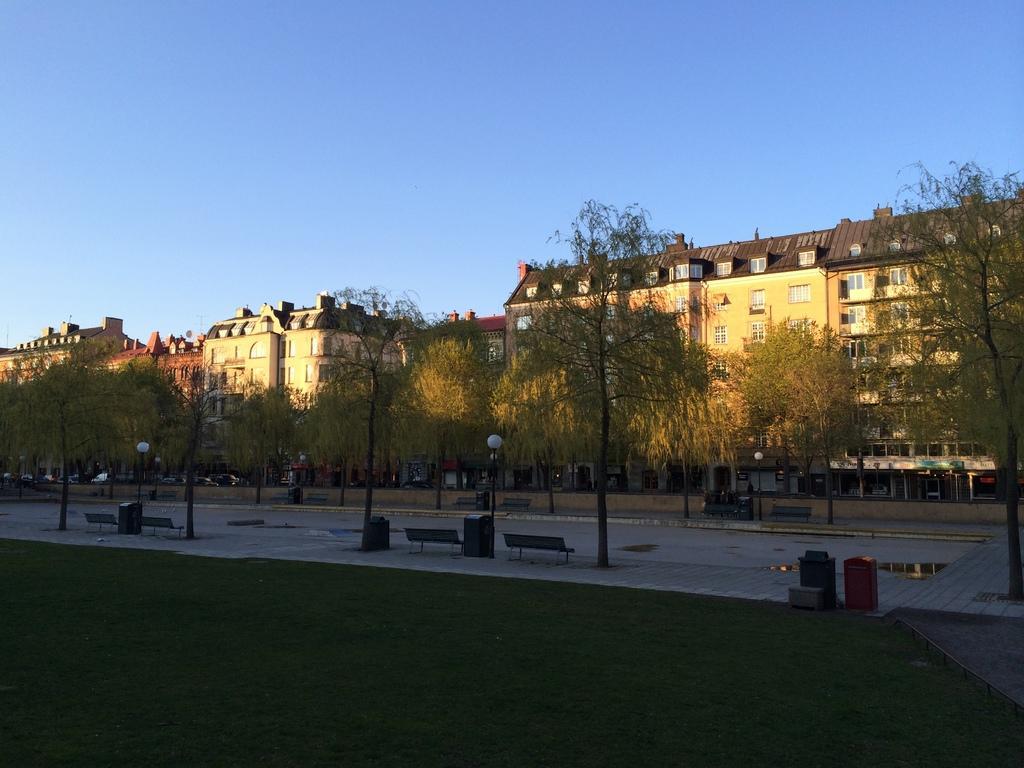Please provide a concise description of this image. In this image I can see the grass, few trees, few benches and few poles. In the background I can see few buildings which are cream and brown in color and the sky. 